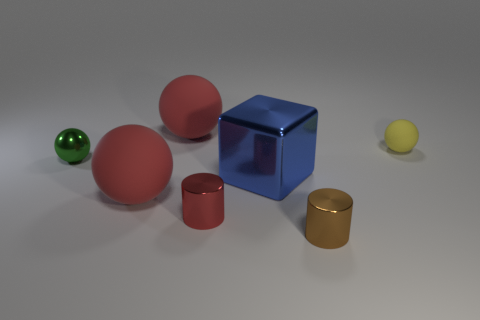Subtract all rubber balls. How many balls are left? 1 Add 2 big gray matte blocks. How many objects exist? 9 Subtract 2 spheres. How many spheres are left? 2 Subtract all cylinders. How many objects are left? 5 Subtract all yellow cubes. How many purple cylinders are left? 0 Subtract all brown metallic balls. Subtract all tiny red shiny cylinders. How many objects are left? 6 Add 3 metal balls. How many metal balls are left? 4 Add 4 metal cubes. How many metal cubes exist? 5 Subtract all red balls. How many balls are left? 2 Subtract 0 purple blocks. How many objects are left? 7 